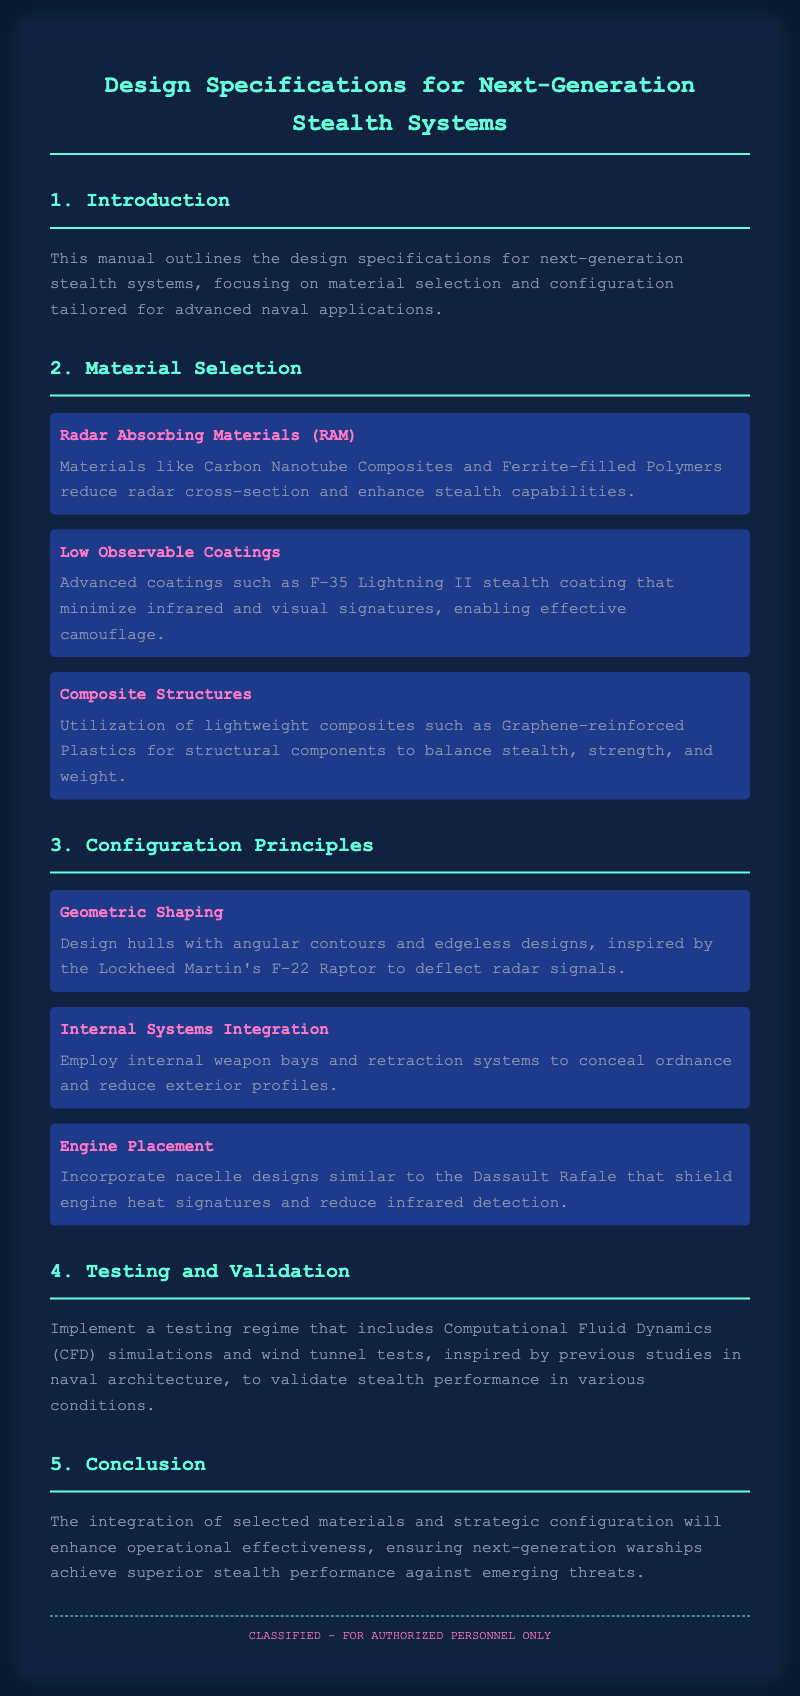What are Radar Absorbing Materials? Radar Absorbing Materials are materials like Carbon Nanotube Composites and Ferrite-filled Polymers that reduce radar cross-section and enhance stealth capabilities.
Answer: Carbon Nanotube Composites and Ferrite-filled Polymers What is the purpose of Low Observable Coatings? Low Observable Coatings, such as F-35 Lightning II stealth coating, minimize infrared and visual signatures, enabling effective camouflage.
Answer: Minimize infrared and visual signatures What type of structures are utilized for balancing stealth, strength, and weight? Composite Structures utilize lightweight composites such as Graphene-reinforced Plastics for structural components.
Answer: Graphene-reinforced Plastics Which geometric shaping method is inspired by the Lockheed Martin's F-22 Raptor? The geometric shaping method is to design hulls with angular contours and edgeless designs to deflect radar signals.
Answer: Angular contours and edgeless designs What is the focus of the testing regime mentioned in the manual? The testing regime focuses on using Computational Fluid Dynamics (CFD) simulations and wind tunnel tests to validate stealth performance.
Answer: CFD simulations and wind tunnel tests How does engine placement contribute to stealth? Engine Placement incorporates nacelle designs similar to the Dassault Rafale that shield engine heat signatures and reduce infrared detection.
Answer: Shield engine heat signatures What is the primary aim of integrating selected materials and configuration strategies? The primary aim is to enhance operational effectiveness and ensure next-generation warships achieve superior stealth performance against emerging threats.
Answer: Enhance operational effectiveness What is the overall theme of the manual? The manual outlines design specifications for next-generation stealth systems, focusing on material selection and configuration tailored for advanced naval applications.
Answer: Design specifications for next-generation stealth systems What type of personnel is the document classified for? The document is classified for authorized personnel only.
Answer: Authorized personnel only 